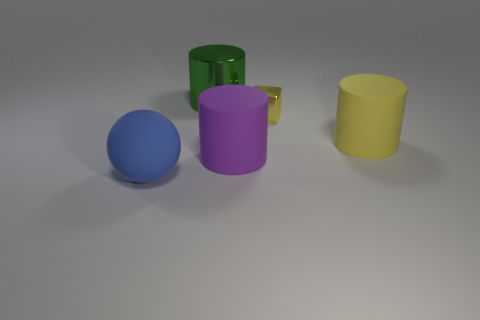Subtract all metal cylinders. How many cylinders are left? 2 Subtract all purple cylinders. How many cylinders are left? 2 Subtract all spheres. How many objects are left? 4 Subtract 2 cylinders. How many cylinders are left? 1 Subtract all yellow cubes. How many green cylinders are left? 1 Subtract all big yellow matte cylinders. Subtract all tiny yellow metal cubes. How many objects are left? 3 Add 1 purple things. How many purple things are left? 2 Add 3 large green metallic cylinders. How many large green metallic cylinders exist? 4 Add 4 yellow metallic cubes. How many objects exist? 9 Subtract 0 green balls. How many objects are left? 5 